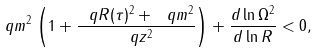<formula> <loc_0><loc_0><loc_500><loc_500>\ q m ^ { 2 } \left ( 1 + \frac { \ q R ( \tau ) ^ { 2 } + \ q m ^ { 2 } } { \ q z ^ { 2 } } \right ) + \frac { d \ln \Omega ^ { 2 } } { d \ln R } < 0 ,</formula> 